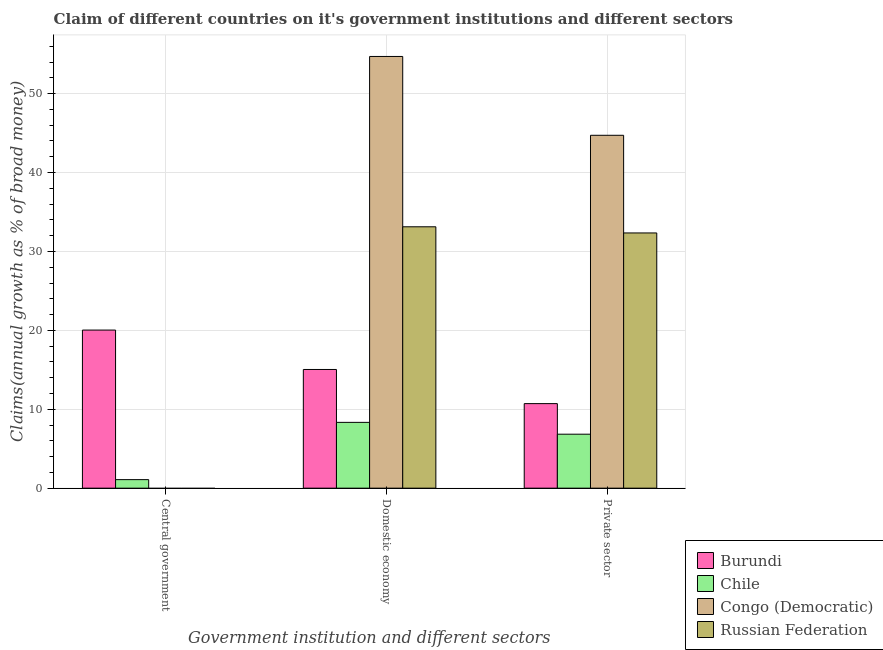How many different coloured bars are there?
Provide a succinct answer. 4. How many groups of bars are there?
Your answer should be compact. 3. How many bars are there on the 1st tick from the left?
Provide a short and direct response. 2. What is the label of the 3rd group of bars from the left?
Offer a very short reply. Private sector. What is the percentage of claim on the domestic economy in Congo (Democratic)?
Give a very brief answer. 54.71. Across all countries, what is the maximum percentage of claim on the domestic economy?
Keep it short and to the point. 54.71. Across all countries, what is the minimum percentage of claim on the domestic economy?
Provide a succinct answer. 8.34. In which country was the percentage of claim on the private sector maximum?
Your response must be concise. Congo (Democratic). What is the total percentage of claim on the private sector in the graph?
Offer a very short reply. 94.62. What is the difference between the percentage of claim on the domestic economy in Burundi and that in Chile?
Offer a very short reply. 6.7. What is the difference between the percentage of claim on the domestic economy in Congo (Democratic) and the percentage of claim on the private sector in Chile?
Give a very brief answer. 47.87. What is the average percentage of claim on the central government per country?
Keep it short and to the point. 5.28. What is the difference between the percentage of claim on the domestic economy and percentage of claim on the central government in Chile?
Offer a terse response. 7.26. What is the ratio of the percentage of claim on the private sector in Burundi to that in Chile?
Your answer should be compact. 1.57. What is the difference between the highest and the second highest percentage of claim on the private sector?
Offer a terse response. 12.38. What is the difference between the highest and the lowest percentage of claim on the central government?
Make the answer very short. 20.04. In how many countries, is the percentage of claim on the domestic economy greater than the average percentage of claim on the domestic economy taken over all countries?
Your answer should be compact. 2. Is the sum of the percentage of claim on the private sector in Russian Federation and Chile greater than the maximum percentage of claim on the central government across all countries?
Offer a terse response. Yes. How many countries are there in the graph?
Provide a short and direct response. 4. Are the values on the major ticks of Y-axis written in scientific E-notation?
Provide a succinct answer. No. How many legend labels are there?
Provide a short and direct response. 4. How are the legend labels stacked?
Offer a terse response. Vertical. What is the title of the graph?
Your answer should be compact. Claim of different countries on it's government institutions and different sectors. What is the label or title of the X-axis?
Make the answer very short. Government institution and different sectors. What is the label or title of the Y-axis?
Keep it short and to the point. Claims(annual growth as % of broad money). What is the Claims(annual growth as % of broad money) in Burundi in Central government?
Provide a short and direct response. 20.04. What is the Claims(annual growth as % of broad money) of Chile in Central government?
Provide a succinct answer. 1.08. What is the Claims(annual growth as % of broad money) in Congo (Democratic) in Central government?
Offer a terse response. 0. What is the Claims(annual growth as % of broad money) in Russian Federation in Central government?
Give a very brief answer. 0. What is the Claims(annual growth as % of broad money) of Burundi in Domestic economy?
Your response must be concise. 15.04. What is the Claims(annual growth as % of broad money) in Chile in Domestic economy?
Provide a short and direct response. 8.34. What is the Claims(annual growth as % of broad money) in Congo (Democratic) in Domestic economy?
Your answer should be very brief. 54.71. What is the Claims(annual growth as % of broad money) of Russian Federation in Domestic economy?
Offer a very short reply. 33.13. What is the Claims(annual growth as % of broad money) of Burundi in Private sector?
Provide a short and direct response. 10.72. What is the Claims(annual growth as % of broad money) in Chile in Private sector?
Provide a short and direct response. 6.84. What is the Claims(annual growth as % of broad money) of Congo (Democratic) in Private sector?
Offer a terse response. 44.72. What is the Claims(annual growth as % of broad money) of Russian Federation in Private sector?
Keep it short and to the point. 32.34. Across all Government institution and different sectors, what is the maximum Claims(annual growth as % of broad money) of Burundi?
Make the answer very short. 20.04. Across all Government institution and different sectors, what is the maximum Claims(annual growth as % of broad money) of Chile?
Your answer should be very brief. 8.34. Across all Government institution and different sectors, what is the maximum Claims(annual growth as % of broad money) in Congo (Democratic)?
Your response must be concise. 54.71. Across all Government institution and different sectors, what is the maximum Claims(annual growth as % of broad money) in Russian Federation?
Make the answer very short. 33.13. Across all Government institution and different sectors, what is the minimum Claims(annual growth as % of broad money) of Burundi?
Provide a short and direct response. 10.72. Across all Government institution and different sectors, what is the minimum Claims(annual growth as % of broad money) of Chile?
Make the answer very short. 1.08. Across all Government institution and different sectors, what is the minimum Claims(annual growth as % of broad money) in Russian Federation?
Offer a very short reply. 0. What is the total Claims(annual growth as % of broad money) in Burundi in the graph?
Provide a short and direct response. 45.79. What is the total Claims(annual growth as % of broad money) in Chile in the graph?
Offer a very short reply. 16.26. What is the total Claims(annual growth as % of broad money) in Congo (Democratic) in the graph?
Make the answer very short. 99.43. What is the total Claims(annual growth as % of broad money) of Russian Federation in the graph?
Offer a very short reply. 65.47. What is the difference between the Claims(annual growth as % of broad money) of Burundi in Central government and that in Domestic economy?
Provide a succinct answer. 4.99. What is the difference between the Claims(annual growth as % of broad money) in Chile in Central government and that in Domestic economy?
Ensure brevity in your answer.  -7.26. What is the difference between the Claims(annual growth as % of broad money) of Burundi in Central government and that in Private sector?
Keep it short and to the point. 9.32. What is the difference between the Claims(annual growth as % of broad money) of Chile in Central government and that in Private sector?
Keep it short and to the point. -5.76. What is the difference between the Claims(annual growth as % of broad money) of Burundi in Domestic economy and that in Private sector?
Offer a very short reply. 4.33. What is the difference between the Claims(annual growth as % of broad money) in Chile in Domestic economy and that in Private sector?
Give a very brief answer. 1.5. What is the difference between the Claims(annual growth as % of broad money) in Congo (Democratic) in Domestic economy and that in Private sector?
Provide a succinct answer. 9.99. What is the difference between the Claims(annual growth as % of broad money) in Russian Federation in Domestic economy and that in Private sector?
Your answer should be very brief. 0.78. What is the difference between the Claims(annual growth as % of broad money) in Burundi in Central government and the Claims(annual growth as % of broad money) in Chile in Domestic economy?
Provide a succinct answer. 11.7. What is the difference between the Claims(annual growth as % of broad money) of Burundi in Central government and the Claims(annual growth as % of broad money) of Congo (Democratic) in Domestic economy?
Provide a short and direct response. -34.68. What is the difference between the Claims(annual growth as % of broad money) of Burundi in Central government and the Claims(annual growth as % of broad money) of Russian Federation in Domestic economy?
Your answer should be very brief. -13.09. What is the difference between the Claims(annual growth as % of broad money) of Chile in Central government and the Claims(annual growth as % of broad money) of Congo (Democratic) in Domestic economy?
Your response must be concise. -53.63. What is the difference between the Claims(annual growth as % of broad money) of Chile in Central government and the Claims(annual growth as % of broad money) of Russian Federation in Domestic economy?
Provide a succinct answer. -32.05. What is the difference between the Claims(annual growth as % of broad money) in Burundi in Central government and the Claims(annual growth as % of broad money) in Chile in Private sector?
Your answer should be very brief. 13.2. What is the difference between the Claims(annual growth as % of broad money) of Burundi in Central government and the Claims(annual growth as % of broad money) of Congo (Democratic) in Private sector?
Provide a succinct answer. -24.69. What is the difference between the Claims(annual growth as % of broad money) of Burundi in Central government and the Claims(annual growth as % of broad money) of Russian Federation in Private sector?
Provide a short and direct response. -12.31. What is the difference between the Claims(annual growth as % of broad money) in Chile in Central government and the Claims(annual growth as % of broad money) in Congo (Democratic) in Private sector?
Ensure brevity in your answer.  -43.64. What is the difference between the Claims(annual growth as % of broad money) in Chile in Central government and the Claims(annual growth as % of broad money) in Russian Federation in Private sector?
Provide a succinct answer. -31.26. What is the difference between the Claims(annual growth as % of broad money) of Burundi in Domestic economy and the Claims(annual growth as % of broad money) of Chile in Private sector?
Offer a terse response. 8.2. What is the difference between the Claims(annual growth as % of broad money) of Burundi in Domestic economy and the Claims(annual growth as % of broad money) of Congo (Democratic) in Private sector?
Provide a succinct answer. -29.68. What is the difference between the Claims(annual growth as % of broad money) in Burundi in Domestic economy and the Claims(annual growth as % of broad money) in Russian Federation in Private sector?
Your response must be concise. -17.3. What is the difference between the Claims(annual growth as % of broad money) of Chile in Domestic economy and the Claims(annual growth as % of broad money) of Congo (Democratic) in Private sector?
Provide a succinct answer. -36.38. What is the difference between the Claims(annual growth as % of broad money) in Chile in Domestic economy and the Claims(annual growth as % of broad money) in Russian Federation in Private sector?
Keep it short and to the point. -24.01. What is the difference between the Claims(annual growth as % of broad money) in Congo (Democratic) in Domestic economy and the Claims(annual growth as % of broad money) in Russian Federation in Private sector?
Your answer should be compact. 22.37. What is the average Claims(annual growth as % of broad money) in Burundi per Government institution and different sectors?
Offer a very short reply. 15.26. What is the average Claims(annual growth as % of broad money) in Chile per Government institution and different sectors?
Provide a short and direct response. 5.42. What is the average Claims(annual growth as % of broad money) in Congo (Democratic) per Government institution and different sectors?
Offer a very short reply. 33.14. What is the average Claims(annual growth as % of broad money) of Russian Federation per Government institution and different sectors?
Your answer should be very brief. 21.82. What is the difference between the Claims(annual growth as % of broad money) of Burundi and Claims(annual growth as % of broad money) of Chile in Central government?
Your response must be concise. 18.96. What is the difference between the Claims(annual growth as % of broad money) in Burundi and Claims(annual growth as % of broad money) in Chile in Domestic economy?
Your response must be concise. 6.7. What is the difference between the Claims(annual growth as % of broad money) of Burundi and Claims(annual growth as % of broad money) of Congo (Democratic) in Domestic economy?
Your answer should be compact. -39.67. What is the difference between the Claims(annual growth as % of broad money) in Burundi and Claims(annual growth as % of broad money) in Russian Federation in Domestic economy?
Your answer should be compact. -18.08. What is the difference between the Claims(annual growth as % of broad money) in Chile and Claims(annual growth as % of broad money) in Congo (Democratic) in Domestic economy?
Make the answer very short. -46.37. What is the difference between the Claims(annual growth as % of broad money) of Chile and Claims(annual growth as % of broad money) of Russian Federation in Domestic economy?
Your answer should be very brief. -24.79. What is the difference between the Claims(annual growth as % of broad money) of Congo (Democratic) and Claims(annual growth as % of broad money) of Russian Federation in Domestic economy?
Offer a very short reply. 21.59. What is the difference between the Claims(annual growth as % of broad money) in Burundi and Claims(annual growth as % of broad money) in Chile in Private sector?
Your response must be concise. 3.88. What is the difference between the Claims(annual growth as % of broad money) in Burundi and Claims(annual growth as % of broad money) in Congo (Democratic) in Private sector?
Your answer should be very brief. -34.01. What is the difference between the Claims(annual growth as % of broad money) of Burundi and Claims(annual growth as % of broad money) of Russian Federation in Private sector?
Give a very brief answer. -21.63. What is the difference between the Claims(annual growth as % of broad money) of Chile and Claims(annual growth as % of broad money) of Congo (Democratic) in Private sector?
Your answer should be compact. -37.88. What is the difference between the Claims(annual growth as % of broad money) of Chile and Claims(annual growth as % of broad money) of Russian Federation in Private sector?
Provide a short and direct response. -25.51. What is the difference between the Claims(annual growth as % of broad money) of Congo (Democratic) and Claims(annual growth as % of broad money) of Russian Federation in Private sector?
Make the answer very short. 12.38. What is the ratio of the Claims(annual growth as % of broad money) in Burundi in Central government to that in Domestic economy?
Your answer should be compact. 1.33. What is the ratio of the Claims(annual growth as % of broad money) of Chile in Central government to that in Domestic economy?
Keep it short and to the point. 0.13. What is the ratio of the Claims(annual growth as % of broad money) of Burundi in Central government to that in Private sector?
Offer a very short reply. 1.87. What is the ratio of the Claims(annual growth as % of broad money) of Chile in Central government to that in Private sector?
Your response must be concise. 0.16. What is the ratio of the Claims(annual growth as % of broad money) of Burundi in Domestic economy to that in Private sector?
Provide a succinct answer. 1.4. What is the ratio of the Claims(annual growth as % of broad money) of Chile in Domestic economy to that in Private sector?
Provide a short and direct response. 1.22. What is the ratio of the Claims(annual growth as % of broad money) of Congo (Democratic) in Domestic economy to that in Private sector?
Keep it short and to the point. 1.22. What is the ratio of the Claims(annual growth as % of broad money) of Russian Federation in Domestic economy to that in Private sector?
Provide a short and direct response. 1.02. What is the difference between the highest and the second highest Claims(annual growth as % of broad money) of Burundi?
Provide a short and direct response. 4.99. What is the difference between the highest and the second highest Claims(annual growth as % of broad money) in Chile?
Make the answer very short. 1.5. What is the difference between the highest and the lowest Claims(annual growth as % of broad money) of Burundi?
Your answer should be very brief. 9.32. What is the difference between the highest and the lowest Claims(annual growth as % of broad money) of Chile?
Ensure brevity in your answer.  7.26. What is the difference between the highest and the lowest Claims(annual growth as % of broad money) in Congo (Democratic)?
Your answer should be compact. 54.71. What is the difference between the highest and the lowest Claims(annual growth as % of broad money) of Russian Federation?
Ensure brevity in your answer.  33.13. 